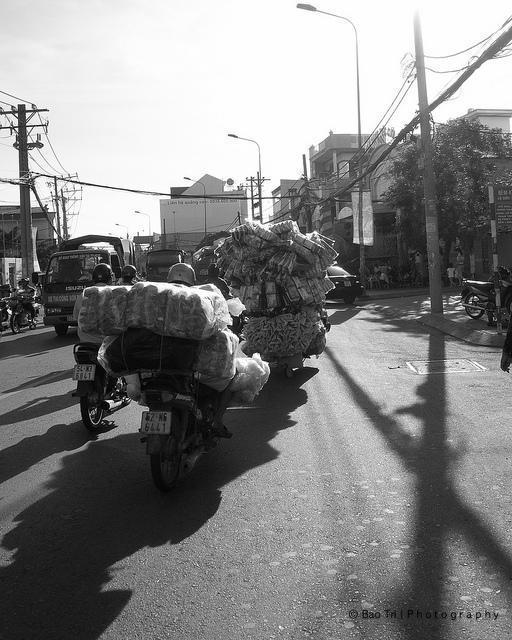How many motorcycles are visible?
Give a very brief answer. 2. 